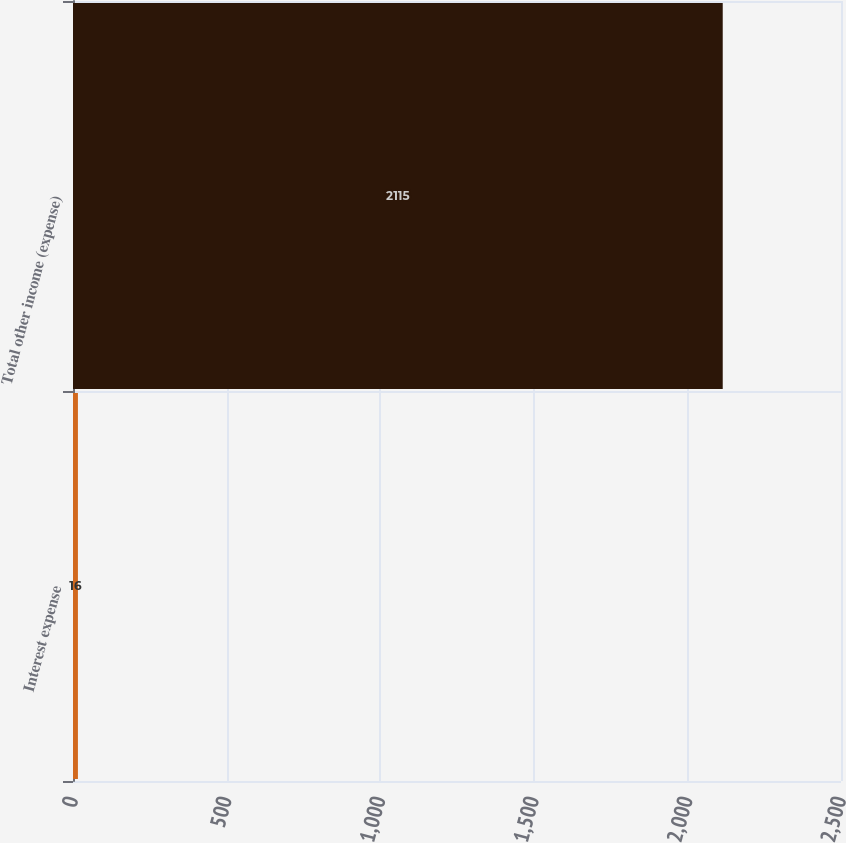Convert chart to OTSL. <chart><loc_0><loc_0><loc_500><loc_500><bar_chart><fcel>Interest expense<fcel>Total other income (expense)<nl><fcel>16<fcel>2115<nl></chart> 